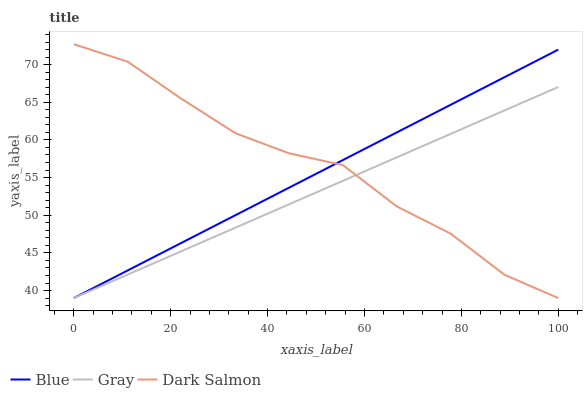Does Gray have the minimum area under the curve?
Answer yes or no. Yes. Does Dark Salmon have the maximum area under the curve?
Answer yes or no. Yes. Does Dark Salmon have the minimum area under the curve?
Answer yes or no. No. Does Gray have the maximum area under the curve?
Answer yes or no. No. Is Gray the smoothest?
Answer yes or no. Yes. Is Dark Salmon the roughest?
Answer yes or no. Yes. Is Dark Salmon the smoothest?
Answer yes or no. No. Is Gray the roughest?
Answer yes or no. No. Does Blue have the lowest value?
Answer yes or no. Yes. Does Dark Salmon have the highest value?
Answer yes or no. Yes. Does Gray have the highest value?
Answer yes or no. No. Does Blue intersect Gray?
Answer yes or no. Yes. Is Blue less than Gray?
Answer yes or no. No. Is Blue greater than Gray?
Answer yes or no. No. 